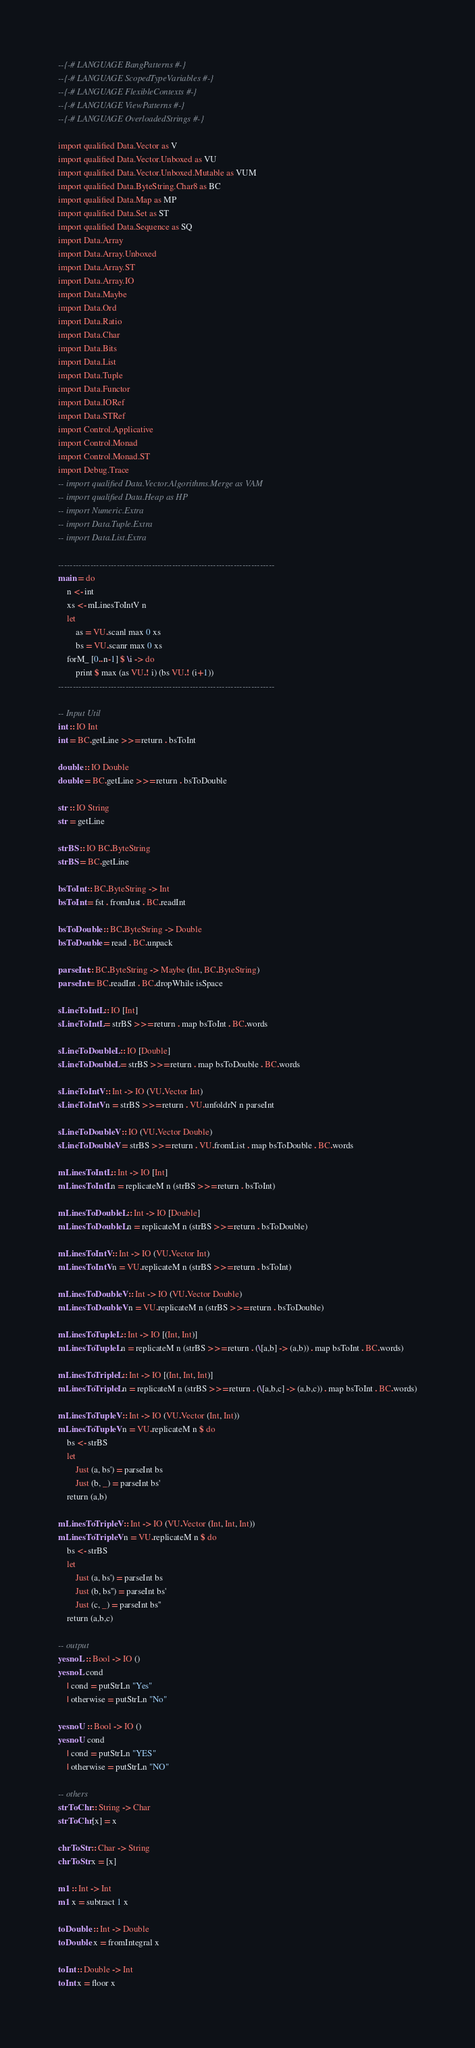<code> <loc_0><loc_0><loc_500><loc_500><_Haskell_>--{-# LANGUAGE BangPatterns #-}
--{-# LANGUAGE ScopedTypeVariables #-}
--{-# LANGUAGE FlexibleContexts #-}
--{-# LANGUAGE ViewPatterns #-}
--{-# LANGUAGE OverloadedStrings #-}

import qualified Data.Vector as V
import qualified Data.Vector.Unboxed as VU
import qualified Data.Vector.Unboxed.Mutable as VUM
import qualified Data.ByteString.Char8 as BC
import qualified Data.Map as MP
import qualified Data.Set as ST
import qualified Data.Sequence as SQ
import Data.Array
import Data.Array.Unboxed
import Data.Array.ST
import Data.Array.IO
import Data.Maybe
import Data.Ord
import Data.Ratio
import Data.Char
import Data.Bits
import Data.List
import Data.Tuple
import Data.Functor
import Data.IORef
import Data.STRef
import Control.Applicative
import Control.Monad
import Control.Monad.ST
import Debug.Trace
-- import qualified Data.Vector.Algorithms.Merge as VAM
-- import qualified Data.Heap as HP
-- import Numeric.Extra
-- import Data.Tuple.Extra
-- import Data.List.Extra

--------------------------------------------------------------------------
main = do
    n <- int
    xs <- mLinesToIntV n
    let
        as = VU.scanl max 0 xs
        bs = VU.scanr max 0 xs
    forM_ [0..n-1] $ \i -> do
        print $ max (as VU.! i) (bs VU.! (i+1))
--------------------------------------------------------------------------

-- Input Util
int :: IO Int
int = BC.getLine >>= return . bsToInt

double :: IO Double
double = BC.getLine >>= return . bsToDouble

str :: IO String
str = getLine

strBS :: IO BC.ByteString
strBS = BC.getLine

bsToInt :: BC.ByteString -> Int
bsToInt = fst . fromJust . BC.readInt

bsToDouble :: BC.ByteString -> Double
bsToDouble = read . BC.unpack

parseInt :: BC.ByteString -> Maybe (Int, BC.ByteString)
parseInt = BC.readInt . BC.dropWhile isSpace

sLineToIntL :: IO [Int]
sLineToIntL = strBS >>= return . map bsToInt . BC.words

sLineToDoubleL :: IO [Double]
sLineToDoubleL = strBS >>= return . map bsToDouble . BC.words

sLineToIntV :: Int -> IO (VU.Vector Int)
sLineToIntV n = strBS >>= return . VU.unfoldrN n parseInt

sLineToDoubleV :: IO (VU.Vector Double)
sLineToDoubleV = strBS >>= return . VU.fromList . map bsToDouble . BC.words

mLinesToIntL :: Int -> IO [Int]
mLinesToIntL n = replicateM n (strBS >>= return . bsToInt)

mLinesToDoubleL :: Int -> IO [Double]
mLinesToDoubleL n = replicateM n (strBS >>= return . bsToDouble)

mLinesToIntV :: Int -> IO (VU.Vector Int)
mLinesToIntV n = VU.replicateM n (strBS >>= return . bsToInt)

mLinesToDoubleV :: Int -> IO (VU.Vector Double)
mLinesToDoubleV n = VU.replicateM n (strBS >>= return . bsToDouble)

mLinesToTupleL :: Int -> IO [(Int, Int)]
mLinesToTupleL n = replicateM n (strBS >>= return . (\[a,b] -> (a,b)) . map bsToInt . BC.words)

mLinesToTripleL :: Int -> IO [(Int, Int, Int)]
mLinesToTripleL n = replicateM n (strBS >>= return . (\[a,b,c] -> (a,b,c)) . map bsToInt . BC.words)

mLinesToTupleV :: Int -> IO (VU.Vector (Int, Int))
mLinesToTupleV n = VU.replicateM n $ do
    bs <- strBS
    let
        Just (a, bs') = parseInt bs
        Just (b, _) = parseInt bs'
    return (a,b)
    
mLinesToTripleV :: Int -> IO (VU.Vector (Int, Int, Int))
mLinesToTripleV n = VU.replicateM n $ do
    bs <- strBS
    let
        Just (a, bs') = parseInt bs
        Just (b, bs'') = parseInt bs'
        Just (c, _) = parseInt bs''
    return (a,b,c)

-- output
yesnoL :: Bool -> IO ()
yesnoL cond
    | cond = putStrLn "Yes"
    | otherwise = putStrLn "No"

yesnoU :: Bool -> IO ()
yesnoU cond
    | cond = putStrLn "YES"
    | otherwise = putStrLn "NO"

-- others
strToChr :: String -> Char
strToChr [x] = x

chrToStr :: Char -> String
chrToStr x = [x]

m1 :: Int -> Int
m1 x = subtract 1 x

toDouble :: Int -> Double
toDouble x = fromIntegral x

toInt :: Double -> Int
toInt x = floor x
</code> 